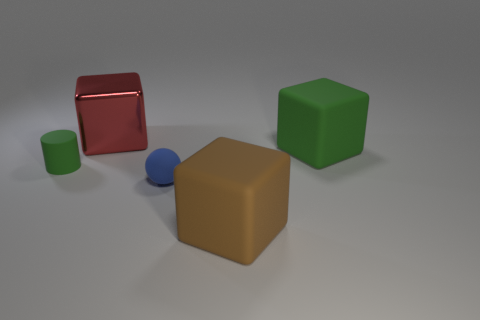Add 5 big gray matte blocks. How many objects exist? 10 Subtract all green cubes. How many cubes are left? 2 Subtract 0 blue blocks. How many objects are left? 5 Subtract all cylinders. How many objects are left? 4 Subtract 3 blocks. How many blocks are left? 0 Subtract all gray cubes. Subtract all brown spheres. How many cubes are left? 3 Subtract all brown cylinders. How many red cubes are left? 1 Subtract all tiny rubber spheres. Subtract all blue objects. How many objects are left? 3 Add 3 tiny green cylinders. How many tiny green cylinders are left? 4 Add 2 large green shiny cubes. How many large green shiny cubes exist? 2 